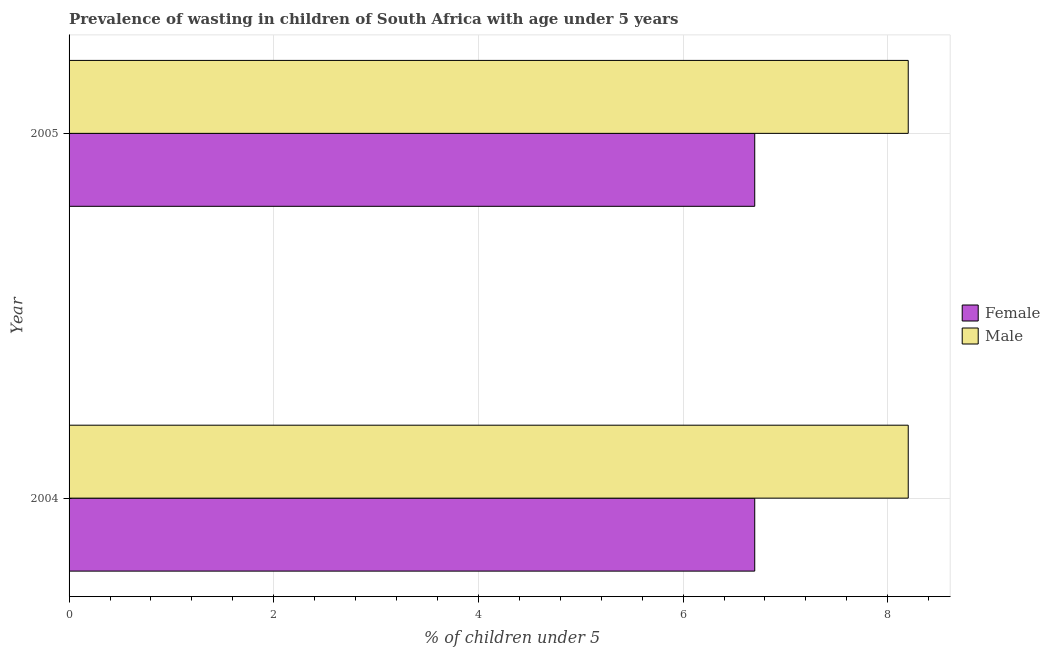Are the number of bars per tick equal to the number of legend labels?
Your answer should be compact. Yes. How many bars are there on the 1st tick from the top?
Provide a succinct answer. 2. What is the percentage of undernourished female children in 2005?
Your response must be concise. 6.7. Across all years, what is the maximum percentage of undernourished male children?
Your answer should be very brief. 8.2. Across all years, what is the minimum percentage of undernourished female children?
Offer a very short reply. 6.7. In which year was the percentage of undernourished female children maximum?
Keep it short and to the point. 2004. What is the total percentage of undernourished male children in the graph?
Provide a succinct answer. 16.4. What is the difference between the percentage of undernourished female children in 2005 and the percentage of undernourished male children in 2004?
Your response must be concise. -1.5. What is the average percentage of undernourished female children per year?
Provide a succinct answer. 6.7. In the year 2004, what is the difference between the percentage of undernourished female children and percentage of undernourished male children?
Give a very brief answer. -1.5. In how many years, is the percentage of undernourished male children greater than the average percentage of undernourished male children taken over all years?
Offer a very short reply. 0. How many bars are there?
Ensure brevity in your answer.  4. What is the difference between two consecutive major ticks on the X-axis?
Your response must be concise. 2. How many legend labels are there?
Give a very brief answer. 2. What is the title of the graph?
Your response must be concise. Prevalence of wasting in children of South Africa with age under 5 years. What is the label or title of the X-axis?
Keep it short and to the point.  % of children under 5. What is the label or title of the Y-axis?
Make the answer very short. Year. What is the  % of children under 5 of Female in 2004?
Give a very brief answer. 6.7. What is the  % of children under 5 in Male in 2004?
Give a very brief answer. 8.2. What is the  % of children under 5 of Female in 2005?
Make the answer very short. 6.7. What is the  % of children under 5 of Male in 2005?
Give a very brief answer. 8.2. Across all years, what is the maximum  % of children under 5 of Female?
Make the answer very short. 6.7. Across all years, what is the maximum  % of children under 5 of Male?
Your answer should be very brief. 8.2. Across all years, what is the minimum  % of children under 5 in Female?
Ensure brevity in your answer.  6.7. Across all years, what is the minimum  % of children under 5 of Male?
Provide a succinct answer. 8.2. What is the total  % of children under 5 of Male in the graph?
Provide a succinct answer. 16.4. What is the difference between the  % of children under 5 in Female in 2004 and that in 2005?
Ensure brevity in your answer.  0. What is the difference between the  % of children under 5 in Male in 2004 and that in 2005?
Offer a terse response. 0. What is the difference between the  % of children under 5 in Female in 2004 and the  % of children under 5 in Male in 2005?
Your answer should be very brief. -1.5. In the year 2004, what is the difference between the  % of children under 5 in Female and  % of children under 5 in Male?
Offer a terse response. -1.5. In the year 2005, what is the difference between the  % of children under 5 in Female and  % of children under 5 in Male?
Offer a terse response. -1.5. What is the ratio of the  % of children under 5 in Female in 2004 to that in 2005?
Provide a succinct answer. 1. What is the ratio of the  % of children under 5 of Male in 2004 to that in 2005?
Provide a short and direct response. 1. What is the difference between the highest and the second highest  % of children under 5 of Female?
Give a very brief answer. 0. 